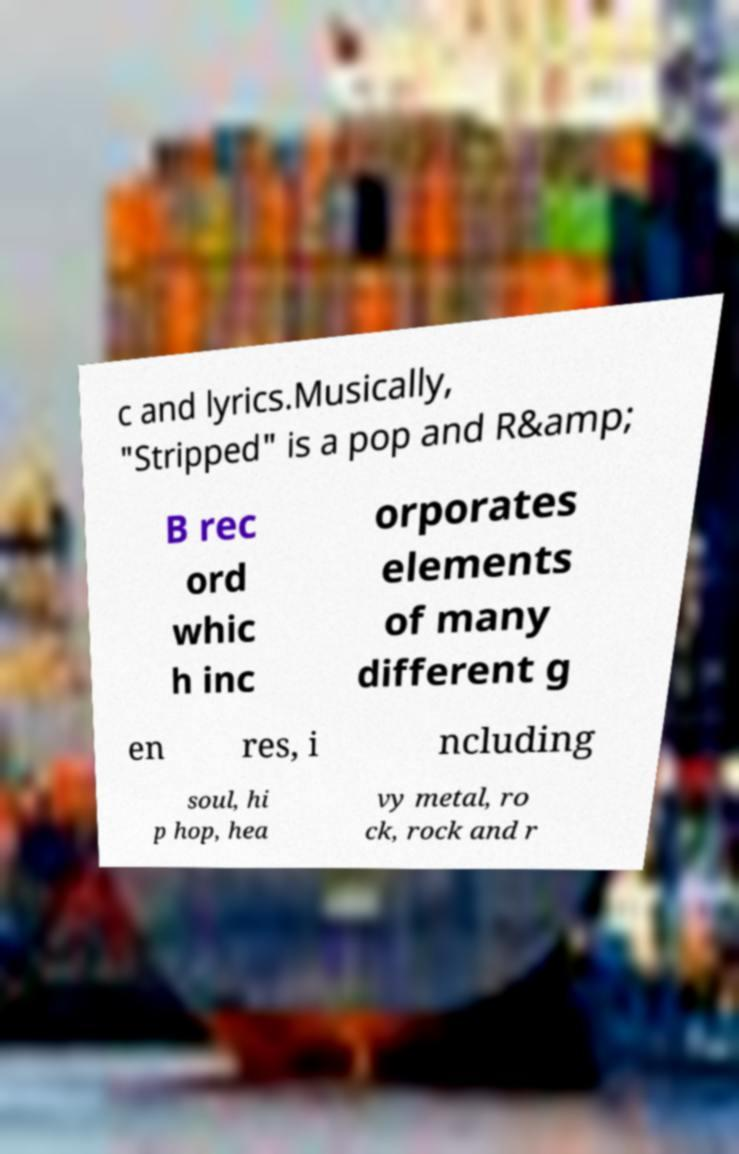What messages or text are displayed in this image? I need them in a readable, typed format. c and lyrics.Musically, "Stripped" is a pop and R&amp; B rec ord whic h inc orporates elements of many different g en res, i ncluding soul, hi p hop, hea vy metal, ro ck, rock and r 